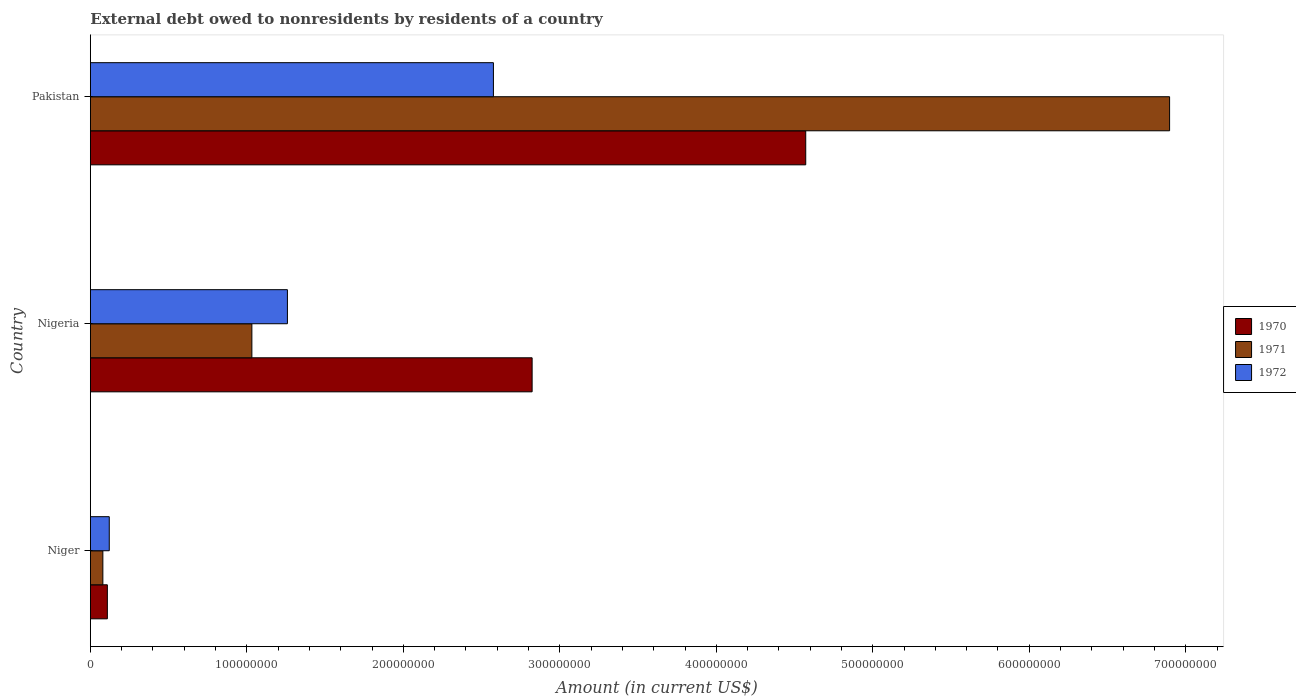How many groups of bars are there?
Your response must be concise. 3. Are the number of bars per tick equal to the number of legend labels?
Your answer should be very brief. Yes. Are the number of bars on each tick of the Y-axis equal?
Provide a short and direct response. Yes. How many bars are there on the 3rd tick from the bottom?
Keep it short and to the point. 3. What is the label of the 2nd group of bars from the top?
Keep it short and to the point. Nigeria. What is the external debt owed by residents in 1971 in Nigeria?
Keep it short and to the point. 1.03e+08. Across all countries, what is the maximum external debt owed by residents in 1971?
Offer a terse response. 6.90e+08. Across all countries, what is the minimum external debt owed by residents in 1971?
Offer a terse response. 7.98e+06. In which country was the external debt owed by residents in 1970 minimum?
Make the answer very short. Niger. What is the total external debt owed by residents in 1971 in the graph?
Your answer should be very brief. 8.01e+08. What is the difference between the external debt owed by residents in 1971 in Niger and that in Pakistan?
Provide a short and direct response. -6.82e+08. What is the difference between the external debt owed by residents in 1972 in Pakistan and the external debt owed by residents in 1970 in Nigeria?
Provide a short and direct response. -2.47e+07. What is the average external debt owed by residents in 1971 per country?
Keep it short and to the point. 2.67e+08. What is the difference between the external debt owed by residents in 1972 and external debt owed by residents in 1971 in Pakistan?
Offer a very short reply. -4.32e+08. In how many countries, is the external debt owed by residents in 1971 greater than 40000000 US$?
Offer a terse response. 2. What is the ratio of the external debt owed by residents in 1971 in Niger to that in Nigeria?
Your response must be concise. 0.08. Is the difference between the external debt owed by residents in 1972 in Niger and Pakistan greater than the difference between the external debt owed by residents in 1971 in Niger and Pakistan?
Offer a very short reply. Yes. What is the difference between the highest and the second highest external debt owed by residents in 1970?
Give a very brief answer. 1.75e+08. What is the difference between the highest and the lowest external debt owed by residents in 1971?
Give a very brief answer. 6.82e+08. In how many countries, is the external debt owed by residents in 1970 greater than the average external debt owed by residents in 1970 taken over all countries?
Offer a terse response. 2. Is the sum of the external debt owed by residents in 1971 in Niger and Nigeria greater than the maximum external debt owed by residents in 1970 across all countries?
Ensure brevity in your answer.  No. What does the 3rd bar from the bottom in Pakistan represents?
Offer a very short reply. 1972. Is it the case that in every country, the sum of the external debt owed by residents in 1972 and external debt owed by residents in 1970 is greater than the external debt owed by residents in 1971?
Give a very brief answer. Yes. How many bars are there?
Provide a succinct answer. 9. Are all the bars in the graph horizontal?
Your response must be concise. Yes. What is the difference between two consecutive major ticks on the X-axis?
Your response must be concise. 1.00e+08. Does the graph contain any zero values?
Ensure brevity in your answer.  No. Does the graph contain grids?
Your answer should be very brief. No. Where does the legend appear in the graph?
Offer a terse response. Center right. What is the title of the graph?
Your answer should be compact. External debt owed to nonresidents by residents of a country. Does "1969" appear as one of the legend labels in the graph?
Your answer should be compact. No. What is the label or title of the X-axis?
Your answer should be very brief. Amount (in current US$). What is the Amount (in current US$) of 1970 in Niger?
Your answer should be compact. 1.09e+07. What is the Amount (in current US$) of 1971 in Niger?
Offer a terse response. 7.98e+06. What is the Amount (in current US$) in 1972 in Niger?
Your response must be concise. 1.21e+07. What is the Amount (in current US$) of 1970 in Nigeria?
Ensure brevity in your answer.  2.82e+08. What is the Amount (in current US$) of 1971 in Nigeria?
Ensure brevity in your answer.  1.03e+08. What is the Amount (in current US$) in 1972 in Nigeria?
Keep it short and to the point. 1.26e+08. What is the Amount (in current US$) in 1970 in Pakistan?
Ensure brevity in your answer.  4.57e+08. What is the Amount (in current US$) of 1971 in Pakistan?
Keep it short and to the point. 6.90e+08. What is the Amount (in current US$) in 1972 in Pakistan?
Make the answer very short. 2.58e+08. Across all countries, what is the maximum Amount (in current US$) of 1970?
Make the answer very short. 4.57e+08. Across all countries, what is the maximum Amount (in current US$) of 1971?
Offer a terse response. 6.90e+08. Across all countries, what is the maximum Amount (in current US$) of 1972?
Offer a terse response. 2.58e+08. Across all countries, what is the minimum Amount (in current US$) of 1970?
Ensure brevity in your answer.  1.09e+07. Across all countries, what is the minimum Amount (in current US$) in 1971?
Offer a terse response. 7.98e+06. Across all countries, what is the minimum Amount (in current US$) of 1972?
Provide a short and direct response. 1.21e+07. What is the total Amount (in current US$) of 1970 in the graph?
Keep it short and to the point. 7.50e+08. What is the total Amount (in current US$) of 1971 in the graph?
Give a very brief answer. 8.01e+08. What is the total Amount (in current US$) of 1972 in the graph?
Provide a short and direct response. 3.96e+08. What is the difference between the Amount (in current US$) of 1970 in Niger and that in Nigeria?
Make the answer very short. -2.71e+08. What is the difference between the Amount (in current US$) in 1971 in Niger and that in Nigeria?
Offer a terse response. -9.52e+07. What is the difference between the Amount (in current US$) in 1972 in Niger and that in Nigeria?
Offer a very short reply. -1.14e+08. What is the difference between the Amount (in current US$) of 1970 in Niger and that in Pakistan?
Your answer should be compact. -4.46e+08. What is the difference between the Amount (in current US$) in 1971 in Niger and that in Pakistan?
Offer a very short reply. -6.82e+08. What is the difference between the Amount (in current US$) in 1972 in Niger and that in Pakistan?
Give a very brief answer. -2.45e+08. What is the difference between the Amount (in current US$) of 1970 in Nigeria and that in Pakistan?
Make the answer very short. -1.75e+08. What is the difference between the Amount (in current US$) in 1971 in Nigeria and that in Pakistan?
Offer a very short reply. -5.86e+08. What is the difference between the Amount (in current US$) of 1972 in Nigeria and that in Pakistan?
Keep it short and to the point. -1.32e+08. What is the difference between the Amount (in current US$) in 1970 in Niger and the Amount (in current US$) in 1971 in Nigeria?
Keep it short and to the point. -9.24e+07. What is the difference between the Amount (in current US$) in 1970 in Niger and the Amount (in current US$) in 1972 in Nigeria?
Provide a succinct answer. -1.15e+08. What is the difference between the Amount (in current US$) of 1971 in Niger and the Amount (in current US$) of 1972 in Nigeria?
Provide a succinct answer. -1.18e+08. What is the difference between the Amount (in current US$) in 1970 in Niger and the Amount (in current US$) in 1971 in Pakistan?
Provide a succinct answer. -6.79e+08. What is the difference between the Amount (in current US$) in 1970 in Niger and the Amount (in current US$) in 1972 in Pakistan?
Your response must be concise. -2.47e+08. What is the difference between the Amount (in current US$) of 1971 in Niger and the Amount (in current US$) of 1972 in Pakistan?
Make the answer very short. -2.50e+08. What is the difference between the Amount (in current US$) in 1970 in Nigeria and the Amount (in current US$) in 1971 in Pakistan?
Ensure brevity in your answer.  -4.07e+08. What is the difference between the Amount (in current US$) in 1970 in Nigeria and the Amount (in current US$) in 1972 in Pakistan?
Your answer should be very brief. 2.47e+07. What is the difference between the Amount (in current US$) of 1971 in Nigeria and the Amount (in current US$) of 1972 in Pakistan?
Give a very brief answer. -1.54e+08. What is the average Amount (in current US$) in 1970 per country?
Provide a succinct answer. 2.50e+08. What is the average Amount (in current US$) in 1971 per country?
Keep it short and to the point. 2.67e+08. What is the average Amount (in current US$) of 1972 per country?
Your answer should be compact. 1.32e+08. What is the difference between the Amount (in current US$) of 1970 and Amount (in current US$) of 1971 in Niger?
Offer a terse response. 2.87e+06. What is the difference between the Amount (in current US$) of 1970 and Amount (in current US$) of 1972 in Niger?
Your response must be concise. -1.22e+06. What is the difference between the Amount (in current US$) of 1971 and Amount (in current US$) of 1972 in Niger?
Give a very brief answer. -4.09e+06. What is the difference between the Amount (in current US$) in 1970 and Amount (in current US$) in 1971 in Nigeria?
Your response must be concise. 1.79e+08. What is the difference between the Amount (in current US$) of 1970 and Amount (in current US$) of 1972 in Nigeria?
Your response must be concise. 1.56e+08. What is the difference between the Amount (in current US$) of 1971 and Amount (in current US$) of 1972 in Nigeria?
Ensure brevity in your answer.  -2.27e+07. What is the difference between the Amount (in current US$) of 1970 and Amount (in current US$) of 1971 in Pakistan?
Offer a terse response. -2.33e+08. What is the difference between the Amount (in current US$) of 1970 and Amount (in current US$) of 1972 in Pakistan?
Ensure brevity in your answer.  2.00e+08. What is the difference between the Amount (in current US$) in 1971 and Amount (in current US$) in 1972 in Pakistan?
Offer a terse response. 4.32e+08. What is the ratio of the Amount (in current US$) in 1970 in Niger to that in Nigeria?
Keep it short and to the point. 0.04. What is the ratio of the Amount (in current US$) in 1971 in Niger to that in Nigeria?
Ensure brevity in your answer.  0.08. What is the ratio of the Amount (in current US$) of 1972 in Niger to that in Nigeria?
Offer a terse response. 0.1. What is the ratio of the Amount (in current US$) of 1970 in Niger to that in Pakistan?
Provide a succinct answer. 0.02. What is the ratio of the Amount (in current US$) in 1971 in Niger to that in Pakistan?
Ensure brevity in your answer.  0.01. What is the ratio of the Amount (in current US$) in 1972 in Niger to that in Pakistan?
Your answer should be compact. 0.05. What is the ratio of the Amount (in current US$) of 1970 in Nigeria to that in Pakistan?
Ensure brevity in your answer.  0.62. What is the ratio of the Amount (in current US$) in 1971 in Nigeria to that in Pakistan?
Keep it short and to the point. 0.15. What is the ratio of the Amount (in current US$) of 1972 in Nigeria to that in Pakistan?
Make the answer very short. 0.49. What is the difference between the highest and the second highest Amount (in current US$) in 1970?
Your answer should be compact. 1.75e+08. What is the difference between the highest and the second highest Amount (in current US$) in 1971?
Your response must be concise. 5.86e+08. What is the difference between the highest and the second highest Amount (in current US$) of 1972?
Keep it short and to the point. 1.32e+08. What is the difference between the highest and the lowest Amount (in current US$) in 1970?
Give a very brief answer. 4.46e+08. What is the difference between the highest and the lowest Amount (in current US$) of 1971?
Provide a short and direct response. 6.82e+08. What is the difference between the highest and the lowest Amount (in current US$) of 1972?
Provide a short and direct response. 2.45e+08. 